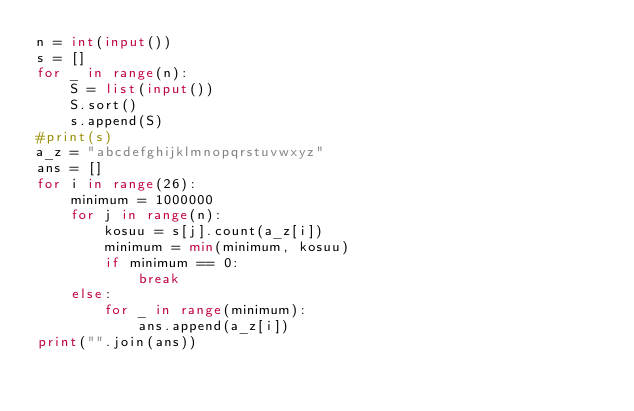<code> <loc_0><loc_0><loc_500><loc_500><_Python_>n = int(input())
s = []
for _ in range(n):
    S = list(input())
    S.sort()
    s.append(S)
#print(s)
a_z = "abcdefghijklmnopqrstuvwxyz"
ans = []
for i in range(26):
    minimum = 1000000
    for j in range(n):
        kosuu = s[j].count(a_z[i])
        minimum = min(minimum, kosuu)
        if minimum == 0:
            break
    else:
        for _ in range(minimum):
            ans.append(a_z[i])
print("".join(ans))

</code> 